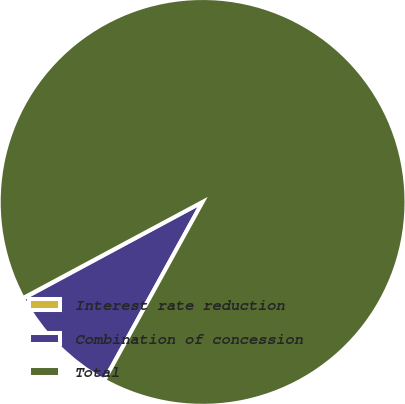Convert chart to OTSL. <chart><loc_0><loc_0><loc_500><loc_500><pie_chart><fcel>Interest rate reduction<fcel>Combination of concession<fcel>Total<nl><fcel>0.04%<fcel>9.12%<fcel>90.85%<nl></chart> 